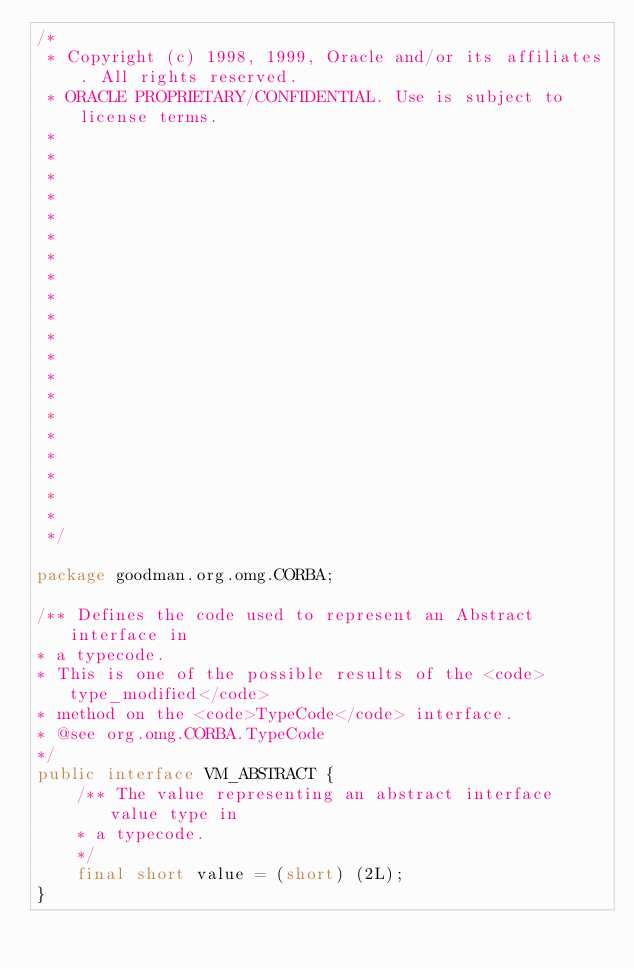Convert code to text. <code><loc_0><loc_0><loc_500><loc_500><_Java_>/*
 * Copyright (c) 1998, 1999, Oracle and/or its affiliates. All rights reserved.
 * ORACLE PROPRIETARY/CONFIDENTIAL. Use is subject to license terms.
 *
 *
 *
 *
 *
 *
 *
 *
 *
 *
 *
 *
 *
 *
 *
 *
 *
 *
 *
 *
 */

package goodman.org.omg.CORBA;

/** Defines the code used to represent an Abstract interface in
* a typecode.
* This is one of the possible results of the <code>type_modified</code>
* method on the <code>TypeCode</code> interface.
* @see org.omg.CORBA.TypeCode
*/
public interface VM_ABSTRACT {
    /** The value representing an abstract interface value type in
    * a typecode.
    */
    final short value = (short) (2L);
}
</code> 